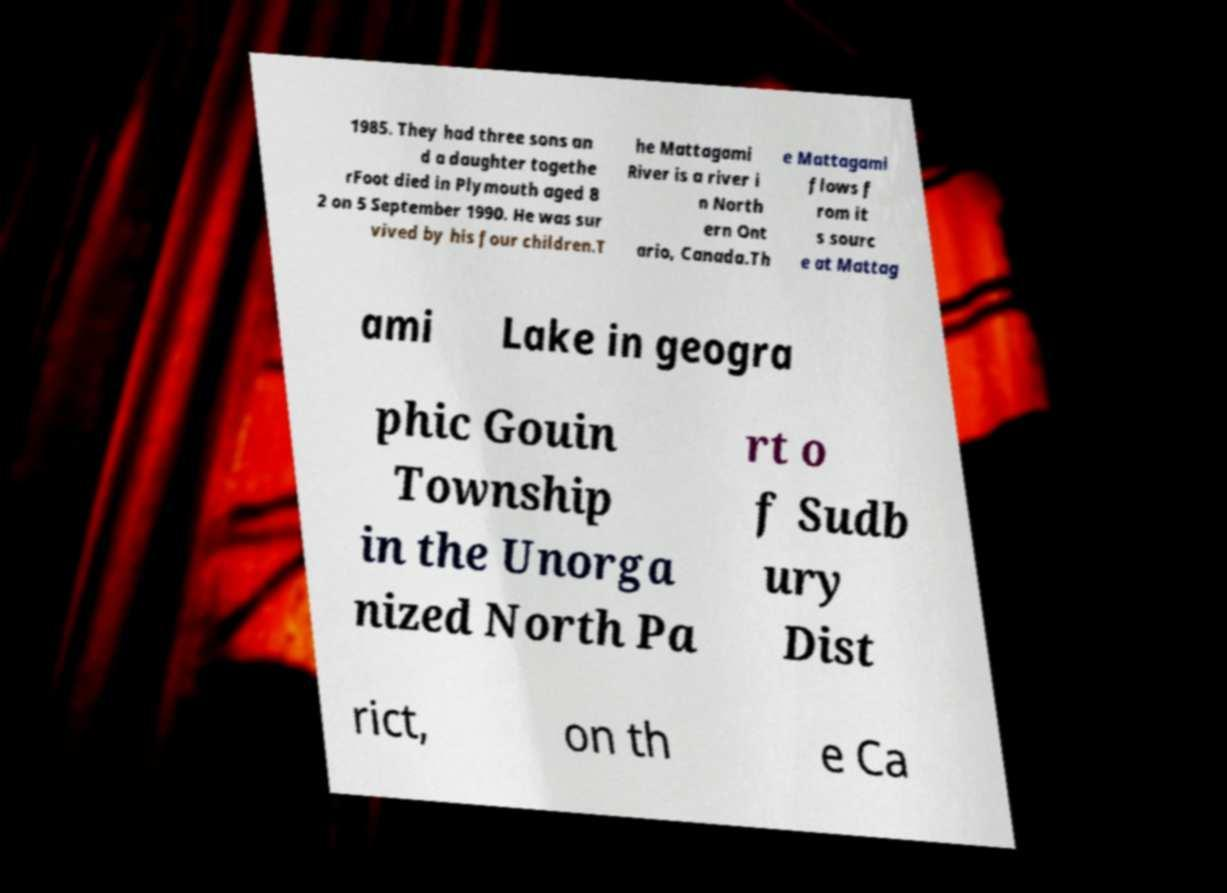Please read and relay the text visible in this image. What does it say? 1985. They had three sons an d a daughter togethe rFoot died in Plymouth aged 8 2 on 5 September 1990. He was sur vived by his four children.T he Mattagami River is a river i n North ern Ont ario, Canada.Th e Mattagami flows f rom it s sourc e at Mattag ami Lake in geogra phic Gouin Township in the Unorga nized North Pa rt o f Sudb ury Dist rict, on th e Ca 